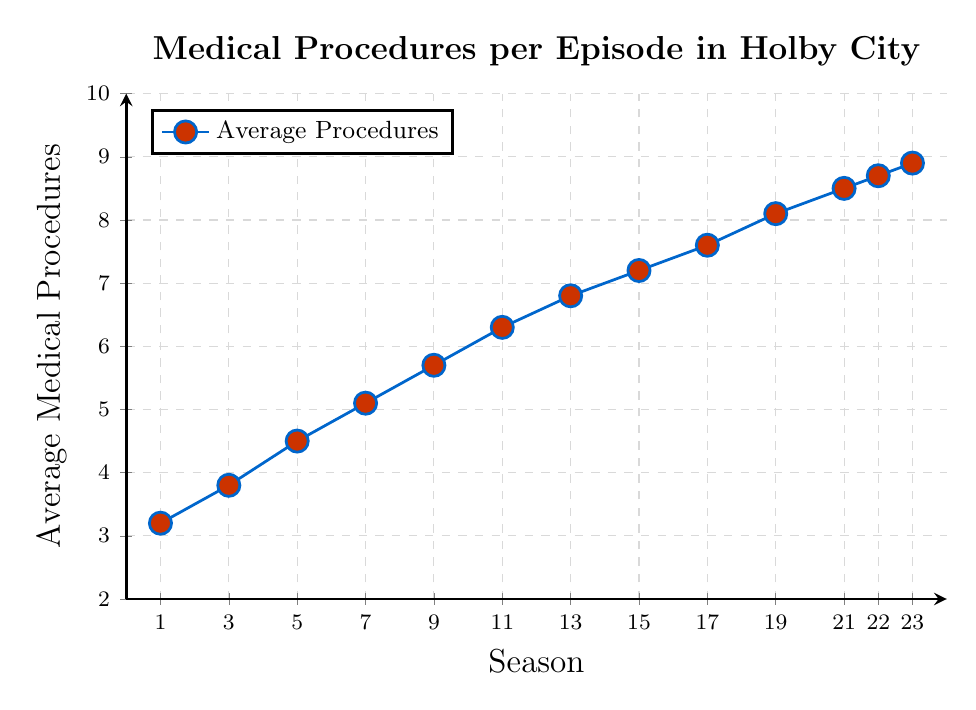How does the number of medical procedures shown in Season 1 compare to Season 23? In Season 1, the average number of medical procedures per episode is 3.2, and in Season 23, it is 8.9. Comparing these, Season 23 has significantly more medical procedures per episode than Season 1.
Answer: Season 23 has more By how much did the average number of medical procedures per episode increase from Season 7 to Season 13? The average number of medical procedures in Season 7 is 5.1 and in Season 13, it is 6.8. The increase is calculated as 6.8 - 5.1 = 1.7.
Answer: 1.7 Which season had the highest average number of medical procedures per episode? From the plot, Season 23 had the highest average number of medical procedures per episode with a value of 8.9.
Answer: Season 23 What is the trend in average medical procedures per episode from Season 1 to Season 23? By observing the line chart, the trend shows a steady increase in the average number of medical procedures per episode from Season 1 (3.2) to Season 23 (8.9).
Answer: Increasing What is the difference in average medical procedures per episode between Season 9 and Season 19? The number of average medical procedures per episode in Season 9 is 5.7 and in Season 19, it is 8.1. The difference is calculated as 8.1 - 5.7 = 2.4.
Answer: 2.4 Which season had an average number of medical procedures per episode closest to 7? Observing the plotted data points, Season 15 had an average of 7.2, which is closest to 7.
Answer: Season 15 How many seasons had an average number of medical procedures less than 4 per episode? From the plot, the seasons with averages less than 4 are Season 1 and Season 3. Therefore, only 2 seasons had an average less than 4.
Answer: 2 Calculate the average number of medical procedures per episode for the first 5 seasons shown in the chart. The seasons are 1, 3, 5, 7, and 9 with averages of 3.2, 3.8, 4.5, 5.1, and 5.7. The average is calculated as (3.2 + 3.8 + 4.5 + 5.1 + 5.7) / 5 = 4.46.
Answer: 4.46 